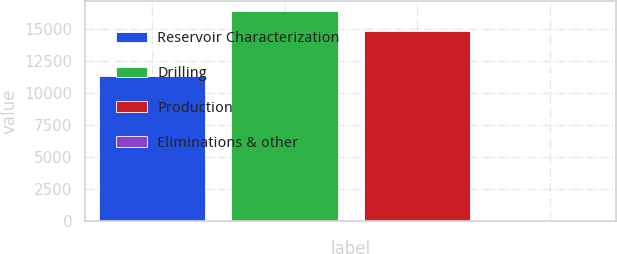Convert chart to OTSL. <chart><loc_0><loc_0><loc_500><loc_500><bar_chart><fcel>Reservoir Characterization<fcel>Drilling<fcel>Production<fcel>Eliminations & other<nl><fcel>11360<fcel>16358.9<fcel>14802<fcel>122<nl></chart> 